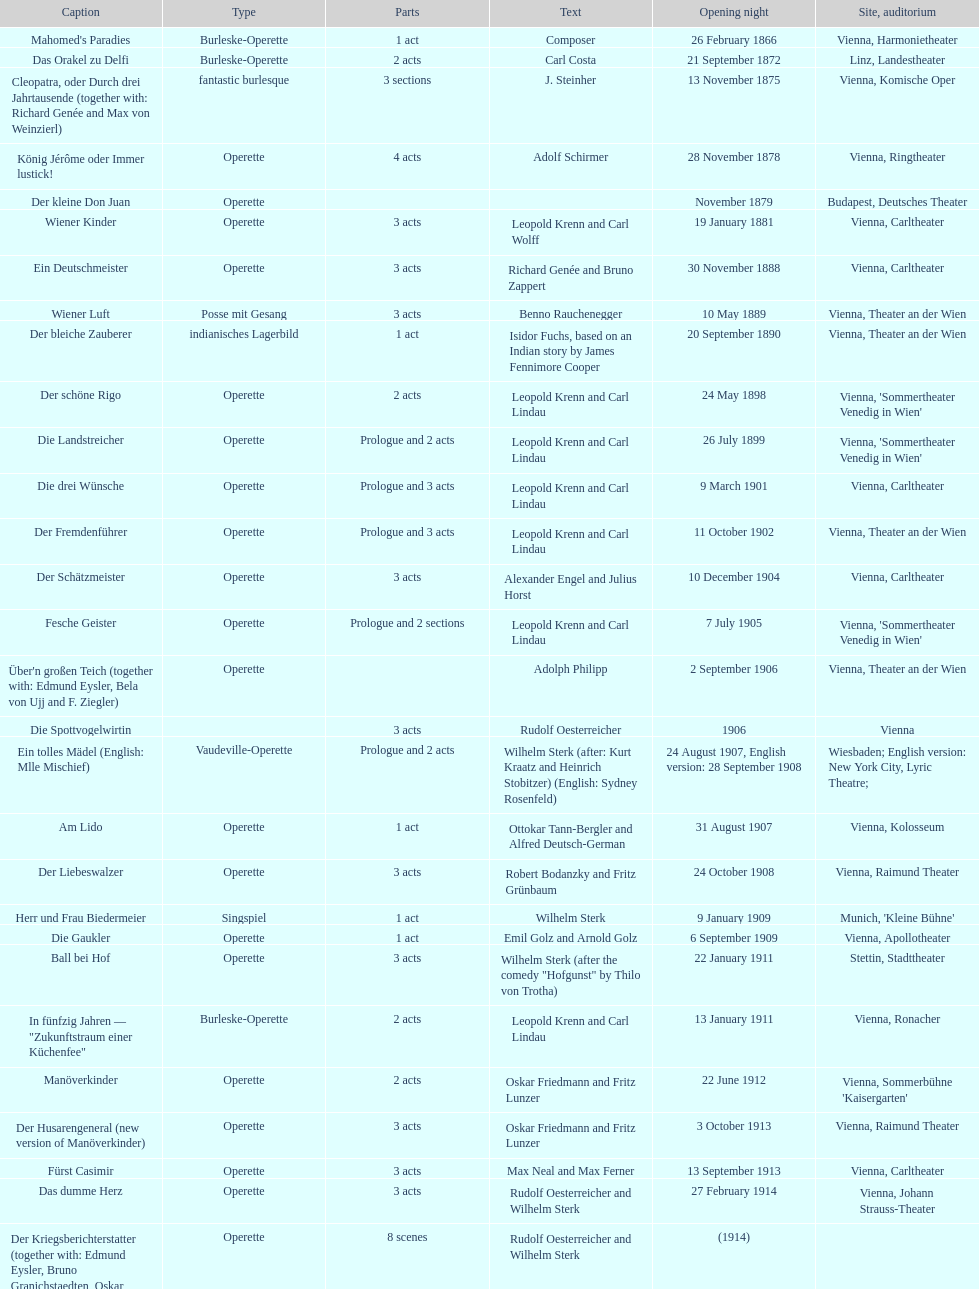How many of his operettas were 3 acts? 13. 